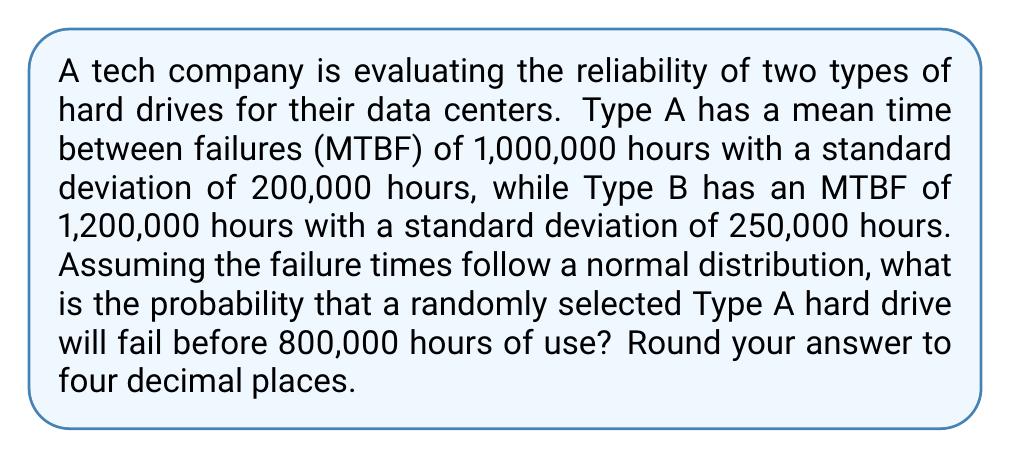Solve this math problem. To solve this problem, we'll use the properties of the normal distribution and the z-score formula:

1) First, we need to calculate the z-score for 800,000 hours of use for Type A hard drives:

   $z = \frac{x - \mu}{\sigma}$

   Where:
   $x$ = 800,000 hours (the time we're interested in)
   $\mu$ = 1,000,000 hours (mean time between failures for Type A)
   $\sigma$ = 200,000 hours (standard deviation for Type A)

2) Plugging in the values:

   $z = \frac{800,000 - 1,000,000}{200,000} = \frac{-200,000}{200,000} = -1$

3) Now that we have the z-score, we need to find the area under the standard normal curve to the left of z = -1. This represents the probability of failure before 800,000 hours.

4) Using a standard normal distribution table or calculator, we find:

   $P(Z < -1) \approx 0.1587$

5) Therefore, the probability that a Type A hard drive will fail before 800,000 hours is approximately 0.1587 or 15.87%.

6) Rounding to four decimal places: 0.1587
Answer: 0.1587 